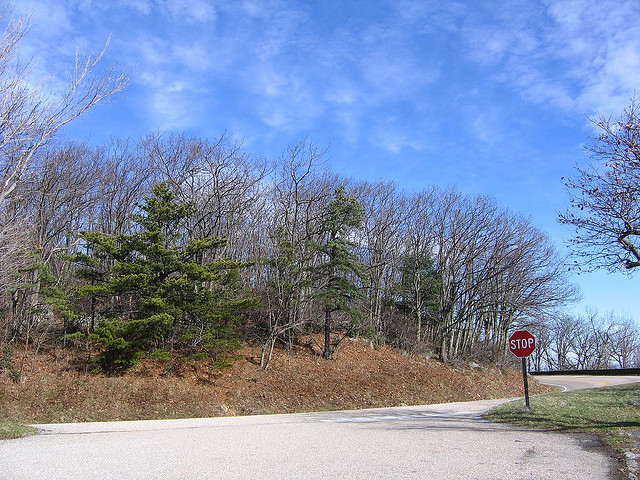What activities might be popular in this area during the season shown? In early spring, activities like hiking, bird watching, and photography are popular in such forested areas due to the mild weather and emerging wildlife. 